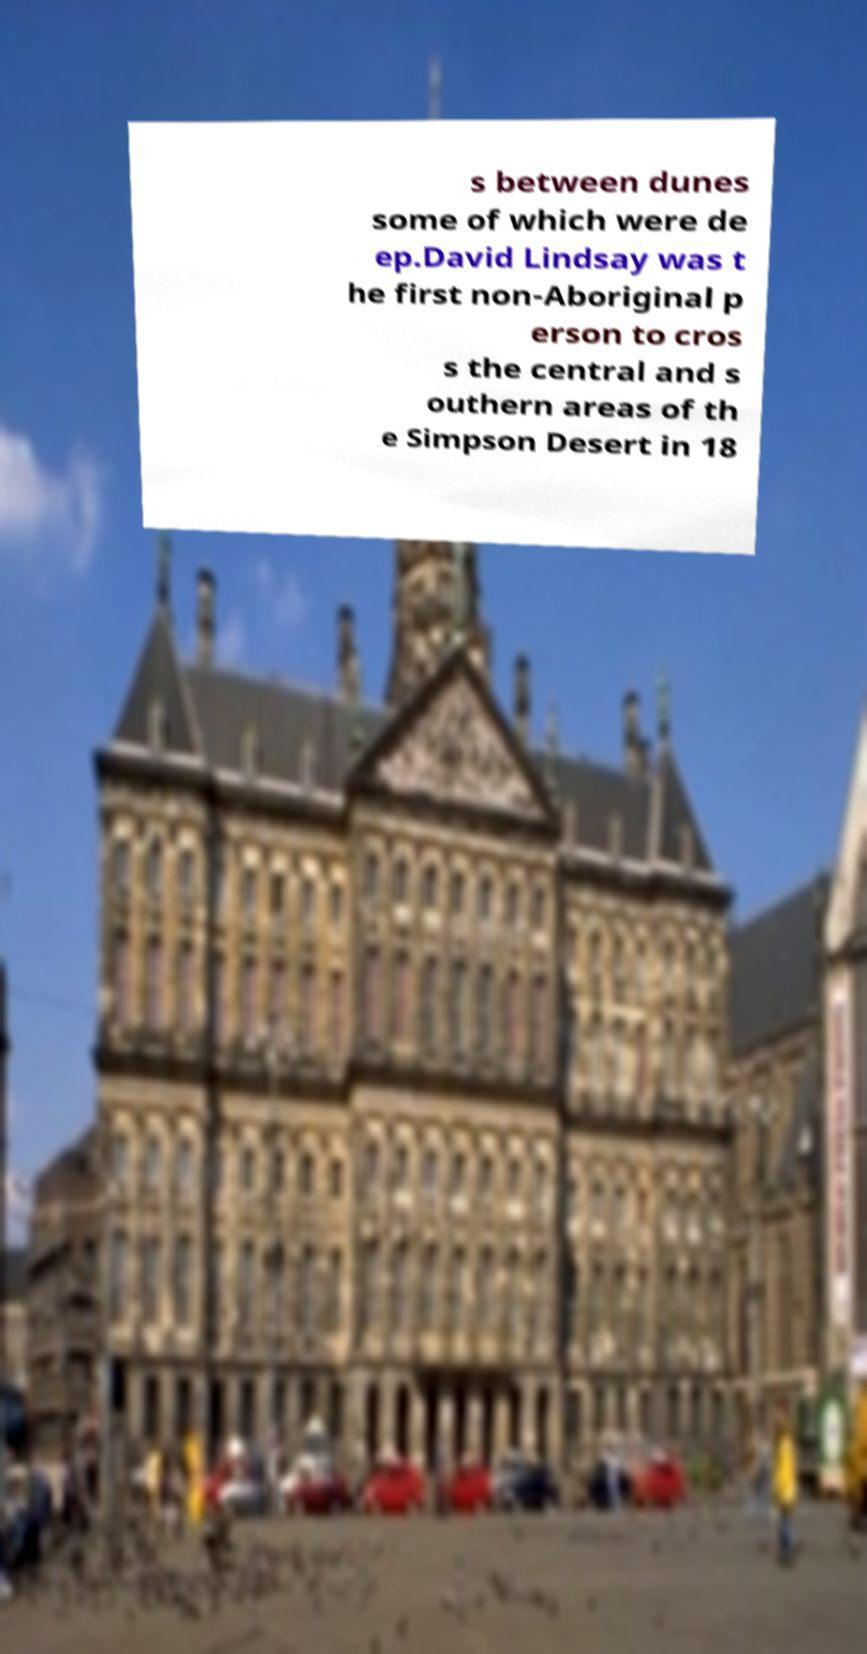There's text embedded in this image that I need extracted. Can you transcribe it verbatim? s between dunes some of which were de ep.David Lindsay was t he first non-Aboriginal p erson to cros s the central and s outhern areas of th e Simpson Desert in 18 